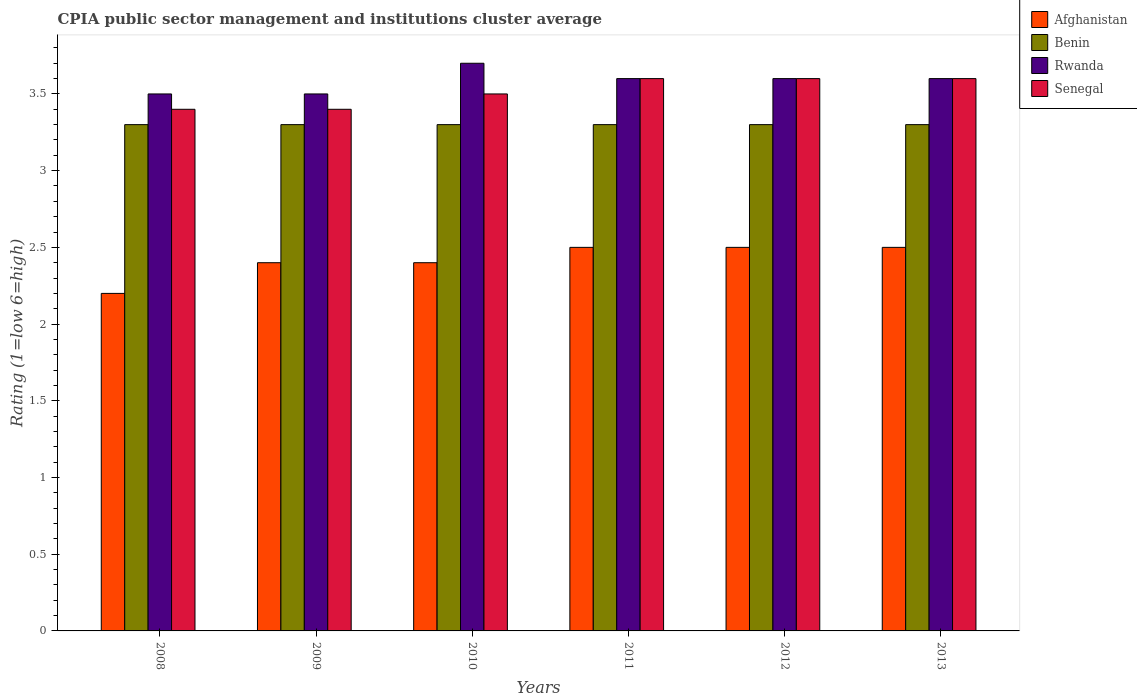How many groups of bars are there?
Your response must be concise. 6. How many bars are there on the 6th tick from the left?
Offer a very short reply. 4. What is the CPIA rating in Benin in 2011?
Offer a terse response. 3.3. Across all years, what is the maximum CPIA rating in Rwanda?
Keep it short and to the point. 3.7. In which year was the CPIA rating in Afghanistan minimum?
Ensure brevity in your answer.  2008. What is the total CPIA rating in Senegal in the graph?
Provide a succinct answer. 21.1. What is the difference between the CPIA rating in Rwanda in 2009 and the CPIA rating in Benin in 2012?
Your response must be concise. 0.2. What is the average CPIA rating in Rwanda per year?
Give a very brief answer. 3.58. In the year 2008, what is the difference between the CPIA rating in Benin and CPIA rating in Senegal?
Your answer should be very brief. -0.1. What is the ratio of the CPIA rating in Rwanda in 2008 to that in 2010?
Give a very brief answer. 0.95. Is the difference between the CPIA rating in Benin in 2008 and 2009 greater than the difference between the CPIA rating in Senegal in 2008 and 2009?
Give a very brief answer. No. What is the difference between the highest and the second highest CPIA rating in Benin?
Offer a very short reply. 0. What is the difference between the highest and the lowest CPIA rating in Senegal?
Make the answer very short. 0.2. In how many years, is the CPIA rating in Benin greater than the average CPIA rating in Benin taken over all years?
Provide a short and direct response. 0. Is it the case that in every year, the sum of the CPIA rating in Afghanistan and CPIA rating in Rwanda is greater than the sum of CPIA rating in Benin and CPIA rating in Senegal?
Your response must be concise. No. What does the 2nd bar from the left in 2011 represents?
Provide a short and direct response. Benin. What does the 1st bar from the right in 2011 represents?
Provide a short and direct response. Senegal. Is it the case that in every year, the sum of the CPIA rating in Benin and CPIA rating in Senegal is greater than the CPIA rating in Afghanistan?
Provide a short and direct response. Yes. How many bars are there?
Keep it short and to the point. 24. How many years are there in the graph?
Give a very brief answer. 6. How many legend labels are there?
Your answer should be very brief. 4. What is the title of the graph?
Your response must be concise. CPIA public sector management and institutions cluster average. What is the label or title of the X-axis?
Make the answer very short. Years. What is the Rating (1=low 6=high) of Afghanistan in 2008?
Make the answer very short. 2.2. What is the Rating (1=low 6=high) of Afghanistan in 2009?
Give a very brief answer. 2.4. What is the Rating (1=low 6=high) in Benin in 2009?
Give a very brief answer. 3.3. What is the Rating (1=low 6=high) in Rwanda in 2009?
Offer a very short reply. 3.5. What is the Rating (1=low 6=high) of Benin in 2010?
Make the answer very short. 3.3. What is the Rating (1=low 6=high) of Rwanda in 2010?
Make the answer very short. 3.7. What is the Rating (1=low 6=high) in Senegal in 2010?
Offer a very short reply. 3.5. What is the Rating (1=low 6=high) of Benin in 2011?
Your response must be concise. 3.3. What is the Rating (1=low 6=high) in Rwanda in 2011?
Your answer should be compact. 3.6. What is the Rating (1=low 6=high) of Afghanistan in 2012?
Provide a succinct answer. 2.5. What is the Rating (1=low 6=high) of Benin in 2012?
Make the answer very short. 3.3. What is the Rating (1=low 6=high) in Benin in 2013?
Your answer should be very brief. 3.3. Across all years, what is the maximum Rating (1=low 6=high) in Afghanistan?
Provide a short and direct response. 2.5. Across all years, what is the maximum Rating (1=low 6=high) in Benin?
Your answer should be very brief. 3.3. Across all years, what is the maximum Rating (1=low 6=high) of Senegal?
Provide a short and direct response. 3.6. Across all years, what is the minimum Rating (1=low 6=high) of Benin?
Offer a very short reply. 3.3. Across all years, what is the minimum Rating (1=low 6=high) of Rwanda?
Give a very brief answer. 3.5. What is the total Rating (1=low 6=high) in Afghanistan in the graph?
Provide a succinct answer. 14.5. What is the total Rating (1=low 6=high) of Benin in the graph?
Make the answer very short. 19.8. What is the total Rating (1=low 6=high) in Rwanda in the graph?
Provide a short and direct response. 21.5. What is the total Rating (1=low 6=high) in Senegal in the graph?
Offer a very short reply. 21.1. What is the difference between the Rating (1=low 6=high) in Benin in 2008 and that in 2009?
Give a very brief answer. 0. What is the difference between the Rating (1=low 6=high) of Rwanda in 2008 and that in 2009?
Ensure brevity in your answer.  0. What is the difference between the Rating (1=low 6=high) of Senegal in 2008 and that in 2009?
Ensure brevity in your answer.  0. What is the difference between the Rating (1=low 6=high) in Afghanistan in 2008 and that in 2010?
Your response must be concise. -0.2. What is the difference between the Rating (1=low 6=high) in Benin in 2008 and that in 2010?
Your answer should be compact. 0. What is the difference between the Rating (1=low 6=high) in Rwanda in 2008 and that in 2010?
Offer a very short reply. -0.2. What is the difference between the Rating (1=low 6=high) of Benin in 2008 and that in 2011?
Make the answer very short. 0. What is the difference between the Rating (1=low 6=high) in Rwanda in 2008 and that in 2012?
Offer a very short reply. -0.1. What is the difference between the Rating (1=low 6=high) of Rwanda in 2008 and that in 2013?
Keep it short and to the point. -0.1. What is the difference between the Rating (1=low 6=high) of Senegal in 2008 and that in 2013?
Offer a terse response. -0.2. What is the difference between the Rating (1=low 6=high) in Afghanistan in 2009 and that in 2010?
Offer a terse response. 0. What is the difference between the Rating (1=low 6=high) in Afghanistan in 2009 and that in 2011?
Provide a short and direct response. -0.1. What is the difference between the Rating (1=low 6=high) in Benin in 2009 and that in 2011?
Your answer should be very brief. 0. What is the difference between the Rating (1=low 6=high) in Senegal in 2009 and that in 2011?
Your answer should be compact. -0.2. What is the difference between the Rating (1=low 6=high) in Benin in 2009 and that in 2012?
Offer a very short reply. 0. What is the difference between the Rating (1=low 6=high) of Rwanda in 2009 and that in 2012?
Offer a very short reply. -0.1. What is the difference between the Rating (1=low 6=high) in Senegal in 2009 and that in 2012?
Ensure brevity in your answer.  -0.2. What is the difference between the Rating (1=low 6=high) of Afghanistan in 2009 and that in 2013?
Keep it short and to the point. -0.1. What is the difference between the Rating (1=low 6=high) of Afghanistan in 2010 and that in 2011?
Provide a short and direct response. -0.1. What is the difference between the Rating (1=low 6=high) of Senegal in 2010 and that in 2012?
Ensure brevity in your answer.  -0.1. What is the difference between the Rating (1=low 6=high) of Benin in 2010 and that in 2013?
Your answer should be very brief. 0. What is the difference between the Rating (1=low 6=high) of Rwanda in 2010 and that in 2013?
Your answer should be compact. 0.1. What is the difference between the Rating (1=low 6=high) in Senegal in 2010 and that in 2013?
Provide a succinct answer. -0.1. What is the difference between the Rating (1=low 6=high) of Afghanistan in 2011 and that in 2012?
Make the answer very short. 0. What is the difference between the Rating (1=low 6=high) of Benin in 2011 and that in 2012?
Offer a very short reply. 0. What is the difference between the Rating (1=low 6=high) in Benin in 2011 and that in 2013?
Your response must be concise. 0. What is the difference between the Rating (1=low 6=high) in Afghanistan in 2012 and that in 2013?
Offer a terse response. 0. What is the difference between the Rating (1=low 6=high) in Senegal in 2012 and that in 2013?
Offer a very short reply. 0. What is the difference between the Rating (1=low 6=high) in Afghanistan in 2008 and the Rating (1=low 6=high) in Benin in 2009?
Your answer should be very brief. -1.1. What is the difference between the Rating (1=low 6=high) in Afghanistan in 2008 and the Rating (1=low 6=high) in Rwanda in 2009?
Your answer should be compact. -1.3. What is the difference between the Rating (1=low 6=high) in Afghanistan in 2008 and the Rating (1=low 6=high) in Senegal in 2009?
Your answer should be very brief. -1.2. What is the difference between the Rating (1=low 6=high) of Benin in 2008 and the Rating (1=low 6=high) of Senegal in 2009?
Provide a succinct answer. -0.1. What is the difference between the Rating (1=low 6=high) in Afghanistan in 2008 and the Rating (1=low 6=high) in Benin in 2010?
Provide a short and direct response. -1.1. What is the difference between the Rating (1=low 6=high) of Afghanistan in 2008 and the Rating (1=low 6=high) of Rwanda in 2010?
Provide a succinct answer. -1.5. What is the difference between the Rating (1=low 6=high) in Afghanistan in 2008 and the Rating (1=low 6=high) in Senegal in 2010?
Your answer should be compact. -1.3. What is the difference between the Rating (1=low 6=high) in Benin in 2008 and the Rating (1=low 6=high) in Senegal in 2010?
Offer a terse response. -0.2. What is the difference between the Rating (1=low 6=high) in Rwanda in 2008 and the Rating (1=low 6=high) in Senegal in 2010?
Your response must be concise. 0. What is the difference between the Rating (1=low 6=high) in Afghanistan in 2008 and the Rating (1=low 6=high) in Rwanda in 2011?
Make the answer very short. -1.4. What is the difference between the Rating (1=low 6=high) in Rwanda in 2008 and the Rating (1=low 6=high) in Senegal in 2011?
Offer a very short reply. -0.1. What is the difference between the Rating (1=low 6=high) in Afghanistan in 2008 and the Rating (1=low 6=high) in Benin in 2012?
Your answer should be very brief. -1.1. What is the difference between the Rating (1=low 6=high) in Afghanistan in 2008 and the Rating (1=low 6=high) in Rwanda in 2012?
Ensure brevity in your answer.  -1.4. What is the difference between the Rating (1=low 6=high) in Benin in 2008 and the Rating (1=low 6=high) in Rwanda in 2012?
Provide a succinct answer. -0.3. What is the difference between the Rating (1=low 6=high) of Rwanda in 2008 and the Rating (1=low 6=high) of Senegal in 2012?
Provide a short and direct response. -0.1. What is the difference between the Rating (1=low 6=high) in Afghanistan in 2008 and the Rating (1=low 6=high) in Benin in 2013?
Offer a terse response. -1.1. What is the difference between the Rating (1=low 6=high) of Benin in 2008 and the Rating (1=low 6=high) of Senegal in 2013?
Ensure brevity in your answer.  -0.3. What is the difference between the Rating (1=low 6=high) in Rwanda in 2008 and the Rating (1=low 6=high) in Senegal in 2013?
Offer a terse response. -0.1. What is the difference between the Rating (1=low 6=high) of Afghanistan in 2009 and the Rating (1=low 6=high) of Benin in 2010?
Ensure brevity in your answer.  -0.9. What is the difference between the Rating (1=low 6=high) in Afghanistan in 2009 and the Rating (1=low 6=high) in Rwanda in 2010?
Your answer should be compact. -1.3. What is the difference between the Rating (1=low 6=high) of Benin in 2009 and the Rating (1=low 6=high) of Senegal in 2010?
Make the answer very short. -0.2. What is the difference between the Rating (1=low 6=high) in Afghanistan in 2009 and the Rating (1=low 6=high) in Benin in 2011?
Keep it short and to the point. -0.9. What is the difference between the Rating (1=low 6=high) in Afghanistan in 2009 and the Rating (1=low 6=high) in Rwanda in 2011?
Your answer should be compact. -1.2. What is the difference between the Rating (1=low 6=high) in Afghanistan in 2009 and the Rating (1=low 6=high) in Senegal in 2011?
Your response must be concise. -1.2. What is the difference between the Rating (1=low 6=high) in Afghanistan in 2009 and the Rating (1=low 6=high) in Benin in 2012?
Give a very brief answer. -0.9. What is the difference between the Rating (1=low 6=high) in Afghanistan in 2009 and the Rating (1=low 6=high) in Rwanda in 2012?
Offer a very short reply. -1.2. What is the difference between the Rating (1=low 6=high) of Rwanda in 2009 and the Rating (1=low 6=high) of Senegal in 2012?
Keep it short and to the point. -0.1. What is the difference between the Rating (1=low 6=high) in Benin in 2009 and the Rating (1=low 6=high) in Rwanda in 2013?
Ensure brevity in your answer.  -0.3. What is the difference between the Rating (1=low 6=high) of Rwanda in 2009 and the Rating (1=low 6=high) of Senegal in 2013?
Make the answer very short. -0.1. What is the difference between the Rating (1=low 6=high) of Afghanistan in 2010 and the Rating (1=low 6=high) of Benin in 2011?
Give a very brief answer. -0.9. What is the difference between the Rating (1=low 6=high) in Afghanistan in 2010 and the Rating (1=low 6=high) in Senegal in 2011?
Keep it short and to the point. -1.2. What is the difference between the Rating (1=low 6=high) of Benin in 2010 and the Rating (1=low 6=high) of Rwanda in 2011?
Offer a very short reply. -0.3. What is the difference between the Rating (1=low 6=high) of Benin in 2010 and the Rating (1=low 6=high) of Senegal in 2011?
Your answer should be very brief. -0.3. What is the difference between the Rating (1=low 6=high) of Rwanda in 2010 and the Rating (1=low 6=high) of Senegal in 2011?
Make the answer very short. 0.1. What is the difference between the Rating (1=low 6=high) in Afghanistan in 2010 and the Rating (1=low 6=high) in Benin in 2012?
Keep it short and to the point. -0.9. What is the difference between the Rating (1=low 6=high) in Afghanistan in 2010 and the Rating (1=low 6=high) in Rwanda in 2012?
Your response must be concise. -1.2. What is the difference between the Rating (1=low 6=high) of Rwanda in 2010 and the Rating (1=low 6=high) of Senegal in 2012?
Give a very brief answer. 0.1. What is the difference between the Rating (1=low 6=high) in Afghanistan in 2010 and the Rating (1=low 6=high) in Senegal in 2013?
Give a very brief answer. -1.2. What is the difference between the Rating (1=low 6=high) of Benin in 2010 and the Rating (1=low 6=high) of Rwanda in 2013?
Your answer should be very brief. -0.3. What is the difference between the Rating (1=low 6=high) in Rwanda in 2011 and the Rating (1=low 6=high) in Senegal in 2012?
Your answer should be compact. 0. What is the difference between the Rating (1=low 6=high) in Afghanistan in 2011 and the Rating (1=low 6=high) in Benin in 2013?
Provide a short and direct response. -0.8. What is the difference between the Rating (1=low 6=high) of Afghanistan in 2011 and the Rating (1=low 6=high) of Rwanda in 2013?
Your answer should be very brief. -1.1. What is the difference between the Rating (1=low 6=high) of Afghanistan in 2011 and the Rating (1=low 6=high) of Senegal in 2013?
Offer a very short reply. -1.1. What is the difference between the Rating (1=low 6=high) in Benin in 2011 and the Rating (1=low 6=high) in Senegal in 2013?
Make the answer very short. -0.3. What is the difference between the Rating (1=low 6=high) in Benin in 2012 and the Rating (1=low 6=high) in Rwanda in 2013?
Ensure brevity in your answer.  -0.3. What is the difference between the Rating (1=low 6=high) in Benin in 2012 and the Rating (1=low 6=high) in Senegal in 2013?
Provide a short and direct response. -0.3. What is the average Rating (1=low 6=high) in Afghanistan per year?
Make the answer very short. 2.42. What is the average Rating (1=low 6=high) of Rwanda per year?
Keep it short and to the point. 3.58. What is the average Rating (1=low 6=high) of Senegal per year?
Provide a short and direct response. 3.52. In the year 2008, what is the difference between the Rating (1=low 6=high) in Afghanistan and Rating (1=low 6=high) in Benin?
Ensure brevity in your answer.  -1.1. In the year 2008, what is the difference between the Rating (1=low 6=high) in Afghanistan and Rating (1=low 6=high) in Senegal?
Ensure brevity in your answer.  -1.2. In the year 2008, what is the difference between the Rating (1=low 6=high) of Benin and Rating (1=low 6=high) of Senegal?
Ensure brevity in your answer.  -0.1. In the year 2008, what is the difference between the Rating (1=low 6=high) of Rwanda and Rating (1=low 6=high) of Senegal?
Ensure brevity in your answer.  0.1. In the year 2009, what is the difference between the Rating (1=low 6=high) of Afghanistan and Rating (1=low 6=high) of Benin?
Keep it short and to the point. -0.9. In the year 2009, what is the difference between the Rating (1=low 6=high) of Afghanistan and Rating (1=low 6=high) of Senegal?
Give a very brief answer. -1. In the year 2010, what is the difference between the Rating (1=low 6=high) in Afghanistan and Rating (1=low 6=high) in Rwanda?
Keep it short and to the point. -1.3. In the year 2010, what is the difference between the Rating (1=low 6=high) of Afghanistan and Rating (1=low 6=high) of Senegal?
Give a very brief answer. -1.1. In the year 2011, what is the difference between the Rating (1=low 6=high) in Afghanistan and Rating (1=low 6=high) in Benin?
Make the answer very short. -0.8. In the year 2011, what is the difference between the Rating (1=low 6=high) in Afghanistan and Rating (1=low 6=high) in Rwanda?
Your answer should be very brief. -1.1. In the year 2011, what is the difference between the Rating (1=low 6=high) in Afghanistan and Rating (1=low 6=high) in Senegal?
Your answer should be compact. -1.1. In the year 2011, what is the difference between the Rating (1=low 6=high) of Benin and Rating (1=low 6=high) of Senegal?
Your response must be concise. -0.3. In the year 2011, what is the difference between the Rating (1=low 6=high) of Rwanda and Rating (1=low 6=high) of Senegal?
Offer a very short reply. 0. In the year 2013, what is the difference between the Rating (1=low 6=high) of Afghanistan and Rating (1=low 6=high) of Benin?
Ensure brevity in your answer.  -0.8. In the year 2013, what is the difference between the Rating (1=low 6=high) in Rwanda and Rating (1=low 6=high) in Senegal?
Provide a short and direct response. 0. What is the ratio of the Rating (1=low 6=high) in Afghanistan in 2008 to that in 2010?
Give a very brief answer. 0.92. What is the ratio of the Rating (1=low 6=high) in Benin in 2008 to that in 2010?
Your answer should be compact. 1. What is the ratio of the Rating (1=low 6=high) of Rwanda in 2008 to that in 2010?
Provide a short and direct response. 0.95. What is the ratio of the Rating (1=low 6=high) of Senegal in 2008 to that in 2010?
Your answer should be very brief. 0.97. What is the ratio of the Rating (1=low 6=high) in Rwanda in 2008 to that in 2011?
Make the answer very short. 0.97. What is the ratio of the Rating (1=low 6=high) in Afghanistan in 2008 to that in 2012?
Offer a terse response. 0.88. What is the ratio of the Rating (1=low 6=high) in Rwanda in 2008 to that in 2012?
Your answer should be compact. 0.97. What is the ratio of the Rating (1=low 6=high) of Senegal in 2008 to that in 2012?
Offer a very short reply. 0.94. What is the ratio of the Rating (1=low 6=high) of Afghanistan in 2008 to that in 2013?
Provide a succinct answer. 0.88. What is the ratio of the Rating (1=low 6=high) of Benin in 2008 to that in 2013?
Keep it short and to the point. 1. What is the ratio of the Rating (1=low 6=high) of Rwanda in 2008 to that in 2013?
Provide a short and direct response. 0.97. What is the ratio of the Rating (1=low 6=high) of Rwanda in 2009 to that in 2010?
Your response must be concise. 0.95. What is the ratio of the Rating (1=low 6=high) in Senegal in 2009 to that in 2010?
Provide a short and direct response. 0.97. What is the ratio of the Rating (1=low 6=high) of Benin in 2009 to that in 2011?
Offer a very short reply. 1. What is the ratio of the Rating (1=low 6=high) of Rwanda in 2009 to that in 2011?
Your answer should be compact. 0.97. What is the ratio of the Rating (1=low 6=high) in Afghanistan in 2009 to that in 2012?
Make the answer very short. 0.96. What is the ratio of the Rating (1=low 6=high) in Benin in 2009 to that in 2012?
Give a very brief answer. 1. What is the ratio of the Rating (1=low 6=high) of Rwanda in 2009 to that in 2012?
Your response must be concise. 0.97. What is the ratio of the Rating (1=low 6=high) in Afghanistan in 2009 to that in 2013?
Ensure brevity in your answer.  0.96. What is the ratio of the Rating (1=low 6=high) in Benin in 2009 to that in 2013?
Provide a short and direct response. 1. What is the ratio of the Rating (1=low 6=high) in Rwanda in 2009 to that in 2013?
Keep it short and to the point. 0.97. What is the ratio of the Rating (1=low 6=high) in Afghanistan in 2010 to that in 2011?
Offer a very short reply. 0.96. What is the ratio of the Rating (1=low 6=high) of Benin in 2010 to that in 2011?
Give a very brief answer. 1. What is the ratio of the Rating (1=low 6=high) of Rwanda in 2010 to that in 2011?
Make the answer very short. 1.03. What is the ratio of the Rating (1=low 6=high) in Senegal in 2010 to that in 2011?
Your answer should be very brief. 0.97. What is the ratio of the Rating (1=low 6=high) of Afghanistan in 2010 to that in 2012?
Provide a short and direct response. 0.96. What is the ratio of the Rating (1=low 6=high) of Benin in 2010 to that in 2012?
Ensure brevity in your answer.  1. What is the ratio of the Rating (1=low 6=high) of Rwanda in 2010 to that in 2012?
Keep it short and to the point. 1.03. What is the ratio of the Rating (1=low 6=high) of Senegal in 2010 to that in 2012?
Give a very brief answer. 0.97. What is the ratio of the Rating (1=low 6=high) in Afghanistan in 2010 to that in 2013?
Give a very brief answer. 0.96. What is the ratio of the Rating (1=low 6=high) in Rwanda in 2010 to that in 2013?
Offer a terse response. 1.03. What is the ratio of the Rating (1=low 6=high) in Senegal in 2010 to that in 2013?
Keep it short and to the point. 0.97. What is the ratio of the Rating (1=low 6=high) of Benin in 2011 to that in 2012?
Ensure brevity in your answer.  1. What is the ratio of the Rating (1=low 6=high) in Rwanda in 2011 to that in 2012?
Offer a terse response. 1. What is the ratio of the Rating (1=low 6=high) in Rwanda in 2011 to that in 2013?
Your answer should be very brief. 1. What is the ratio of the Rating (1=low 6=high) of Senegal in 2011 to that in 2013?
Make the answer very short. 1. What is the ratio of the Rating (1=low 6=high) in Benin in 2012 to that in 2013?
Make the answer very short. 1. What is the difference between the highest and the second highest Rating (1=low 6=high) of Benin?
Your answer should be very brief. 0. What is the difference between the highest and the second highest Rating (1=low 6=high) of Rwanda?
Keep it short and to the point. 0.1. What is the difference between the highest and the second highest Rating (1=low 6=high) in Senegal?
Make the answer very short. 0. What is the difference between the highest and the lowest Rating (1=low 6=high) in Benin?
Offer a terse response. 0. What is the difference between the highest and the lowest Rating (1=low 6=high) in Senegal?
Your response must be concise. 0.2. 